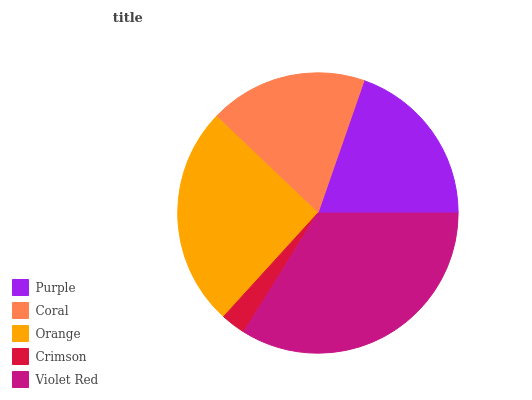Is Crimson the minimum?
Answer yes or no. Yes. Is Violet Red the maximum?
Answer yes or no. Yes. Is Coral the minimum?
Answer yes or no. No. Is Coral the maximum?
Answer yes or no. No. Is Purple greater than Coral?
Answer yes or no. Yes. Is Coral less than Purple?
Answer yes or no. Yes. Is Coral greater than Purple?
Answer yes or no. No. Is Purple less than Coral?
Answer yes or no. No. Is Purple the high median?
Answer yes or no. Yes. Is Purple the low median?
Answer yes or no. Yes. Is Orange the high median?
Answer yes or no. No. Is Coral the low median?
Answer yes or no. No. 